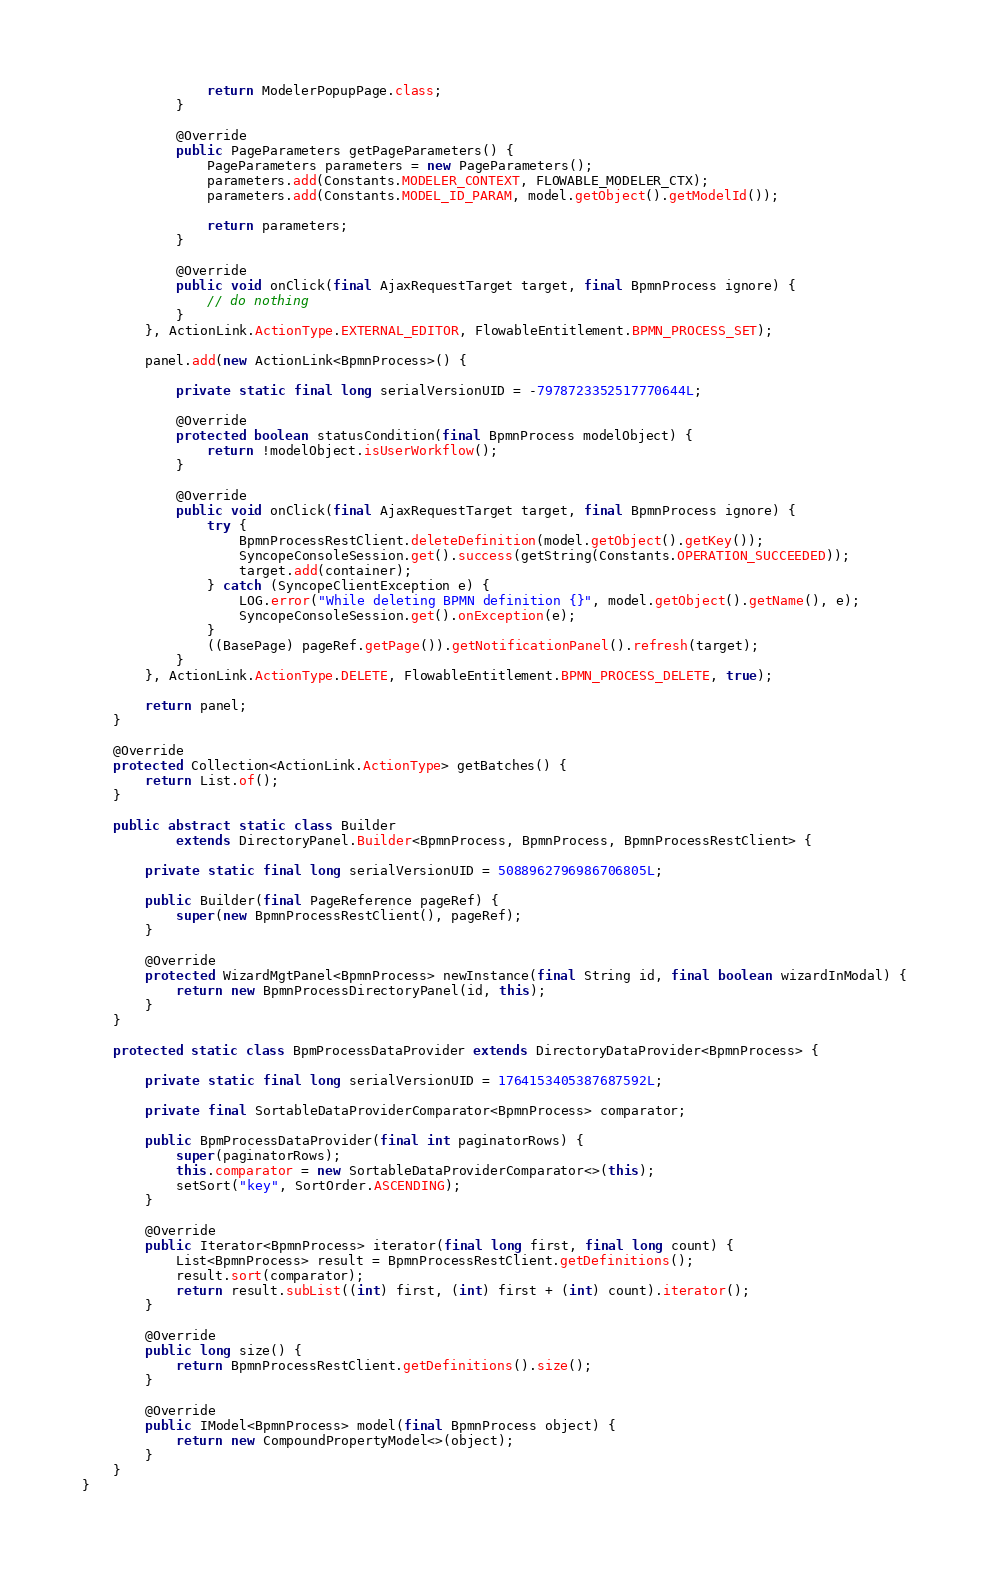Convert code to text. <code><loc_0><loc_0><loc_500><loc_500><_Java_>                return ModelerPopupPage.class;
            }

            @Override
            public PageParameters getPageParameters() {
                PageParameters parameters = new PageParameters();
                parameters.add(Constants.MODELER_CONTEXT, FLOWABLE_MODELER_CTX);
                parameters.add(Constants.MODEL_ID_PARAM, model.getObject().getModelId());

                return parameters;
            }

            @Override
            public void onClick(final AjaxRequestTarget target, final BpmnProcess ignore) {
                // do nothing
            }
        }, ActionLink.ActionType.EXTERNAL_EDITOR, FlowableEntitlement.BPMN_PROCESS_SET);

        panel.add(new ActionLink<BpmnProcess>() {

            private static final long serialVersionUID = -7978723352517770644L;

            @Override
            protected boolean statusCondition(final BpmnProcess modelObject) {
                return !modelObject.isUserWorkflow();
            }

            @Override
            public void onClick(final AjaxRequestTarget target, final BpmnProcess ignore) {
                try {
                    BpmnProcessRestClient.deleteDefinition(model.getObject().getKey());
                    SyncopeConsoleSession.get().success(getString(Constants.OPERATION_SUCCEEDED));
                    target.add(container);
                } catch (SyncopeClientException e) {
                    LOG.error("While deleting BPMN definition {}", model.getObject().getName(), e);
                    SyncopeConsoleSession.get().onException(e);
                }
                ((BasePage) pageRef.getPage()).getNotificationPanel().refresh(target);
            }
        }, ActionLink.ActionType.DELETE, FlowableEntitlement.BPMN_PROCESS_DELETE, true);

        return panel;
    }

    @Override
    protected Collection<ActionLink.ActionType> getBatches() {
        return List.of();
    }

    public abstract static class Builder
            extends DirectoryPanel.Builder<BpmnProcess, BpmnProcess, BpmnProcessRestClient> {

        private static final long serialVersionUID = 5088962796986706805L;

        public Builder(final PageReference pageRef) {
            super(new BpmnProcessRestClient(), pageRef);
        }

        @Override
        protected WizardMgtPanel<BpmnProcess> newInstance(final String id, final boolean wizardInModal) {
            return new BpmnProcessDirectoryPanel(id, this);
        }
    }

    protected static class BpmProcessDataProvider extends DirectoryDataProvider<BpmnProcess> {

        private static final long serialVersionUID = 1764153405387687592L;

        private final SortableDataProviderComparator<BpmnProcess> comparator;

        public BpmProcessDataProvider(final int paginatorRows) {
            super(paginatorRows);
            this.comparator = new SortableDataProviderComparator<>(this);
            setSort("key", SortOrder.ASCENDING);
        }

        @Override
        public Iterator<BpmnProcess> iterator(final long first, final long count) {
            List<BpmnProcess> result = BpmnProcessRestClient.getDefinitions();
            result.sort(comparator);
            return result.subList((int) first, (int) first + (int) count).iterator();
        }

        @Override
        public long size() {
            return BpmnProcessRestClient.getDefinitions().size();
        }

        @Override
        public IModel<BpmnProcess> model(final BpmnProcess object) {
            return new CompoundPropertyModel<>(object);
        }
    }
}
</code> 